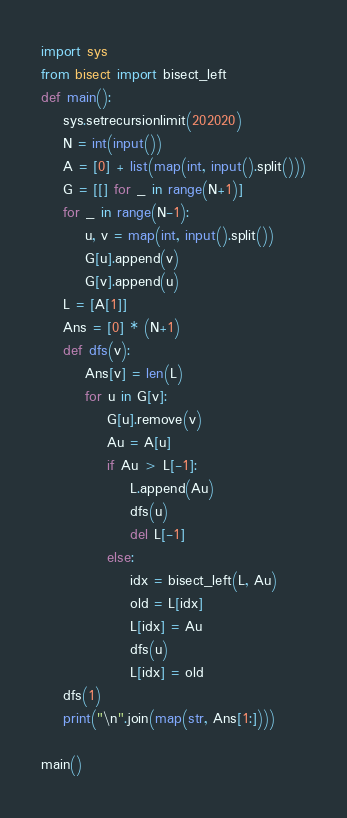<code> <loc_0><loc_0><loc_500><loc_500><_Python_>import sys
from bisect import bisect_left
def main():
    sys.setrecursionlimit(202020)
    N = int(input())
    A = [0] + list(map(int, input().split()))
    G = [[] for _ in range(N+1)]
    for _ in range(N-1):
        u, v = map(int, input().split())
        G[u].append(v)
        G[v].append(u)
    L = [A[1]]
    Ans = [0] * (N+1)
    def dfs(v):
        Ans[v] = len(L)
        for u in G[v]:
            G[u].remove(v)
            Au = A[u]
            if Au > L[-1]:
                L.append(Au)
                dfs(u)
                del L[-1]
            else:
                idx = bisect_left(L, Au)
                old = L[idx]
                L[idx] = Au
                dfs(u)
                L[idx] = old
    dfs(1)
    print("\n".join(map(str, Ans[1:])))

main()
</code> 